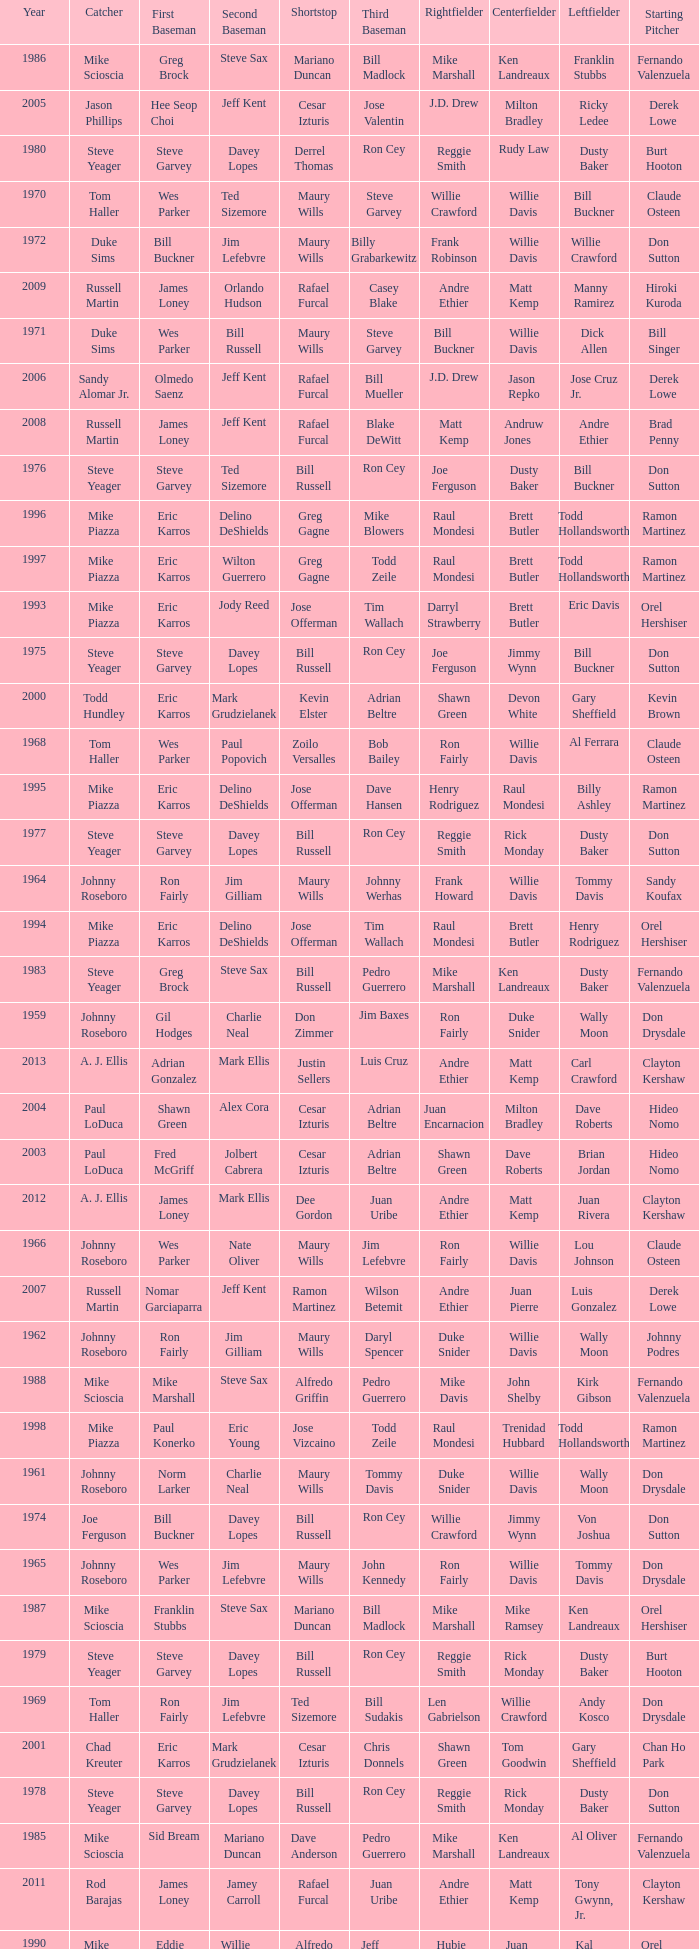Who played 2nd base when nomar garciaparra was at 1st base? Jeff Kent. 